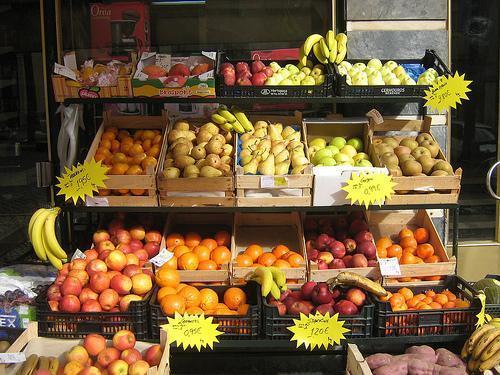How many bunches of bananas are in the picture?
Give a very brief answer. 5. 